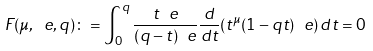<formula> <loc_0><loc_0><loc_500><loc_500>F ( \mu , \ e , q ) \colon = \int _ { 0 } ^ { q } \frac { t ^ { \ } e } { ( q - t ) ^ { \ } e } \frac { d } { d t } ( t ^ { \mu } ( 1 - q t ) ^ { \ } e ) \, d t = 0</formula> 